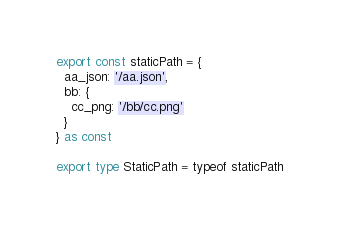<code> <loc_0><loc_0><loc_500><loc_500><_TypeScript_>export const staticPath = {
  aa_json: '/aa.json',
  bb: {
    cc_png: '/bb/cc.png'
  }
} as const

export type StaticPath = typeof staticPath
</code> 